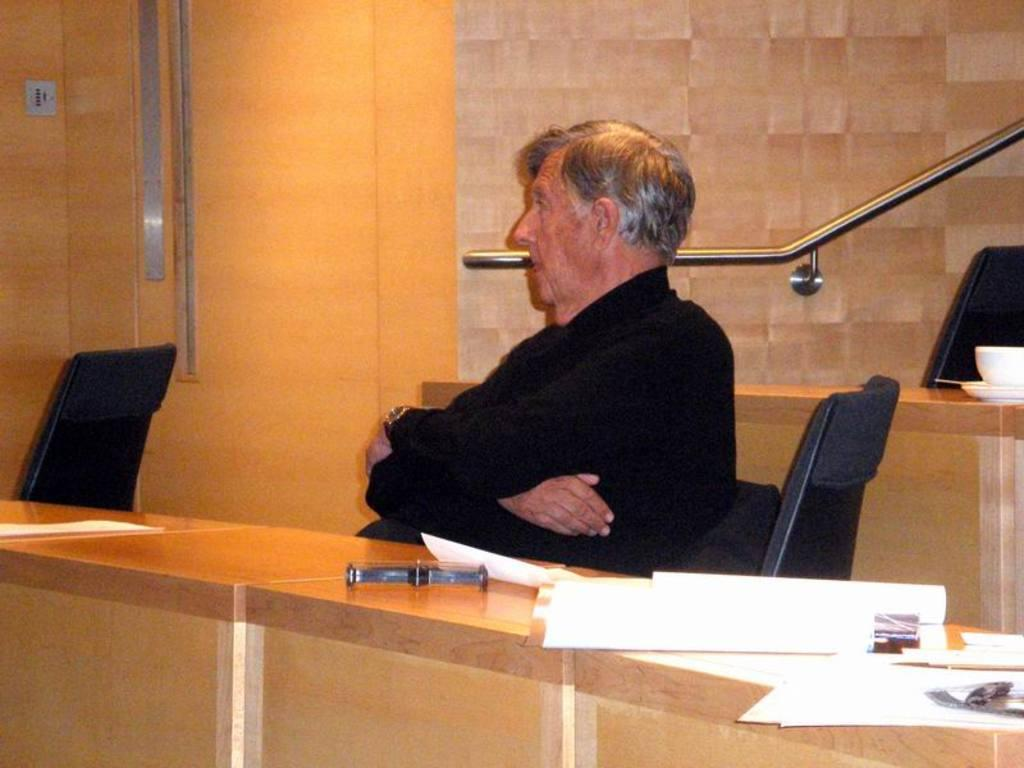What is the main subject of the image? There is a man in the image. What is the man doing in the image? The man is sitting on a chair. What is in front of the man? There is a table in front of the man. What is on the table? There are papers on the table. What is behind the man? There is an iron rod at the back of the man. What type of beef is being served on the table in the image? There is no beef present in the image; it only shows a man sitting on a chair with a table and papers in front of him. How many goldfish are swimming in the iron rod behind the man? There are no goldfish present in the image; it only shows an iron rod behind the man. 